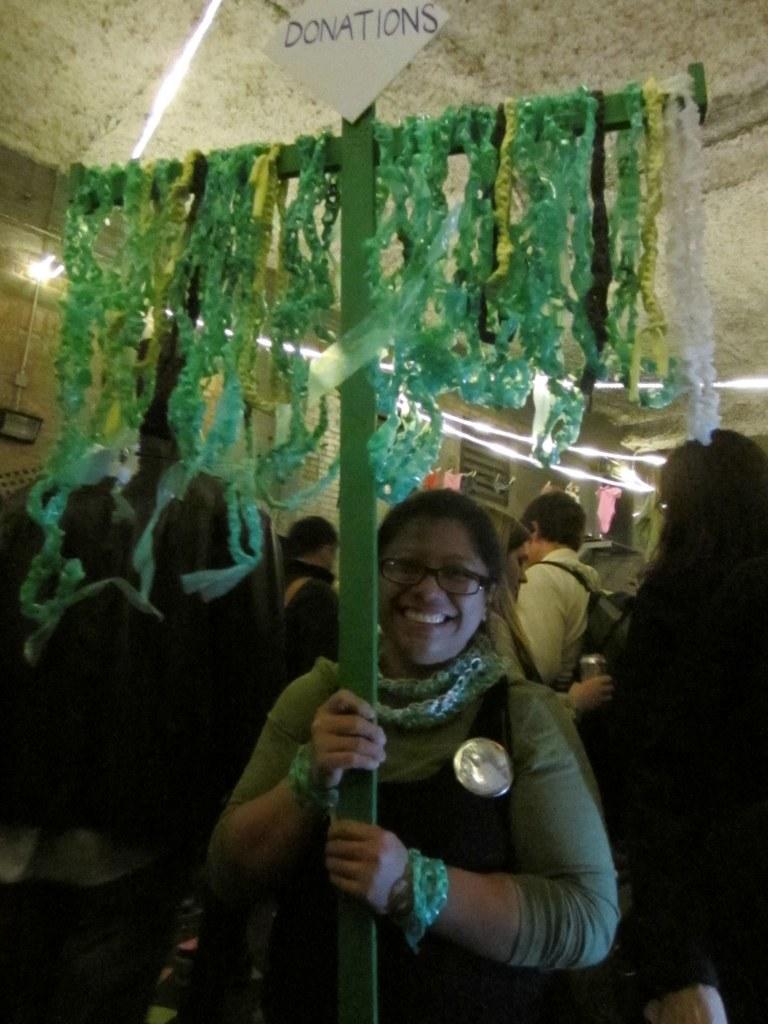How would you summarize this image in a sentence or two? In this image I can see number of people are standing. Here I can see she is wearing specs and I can also see smile on her face. I can see a green colour pole, a white colour board, lights and few colourful things over here. On this board I can see something is written. 